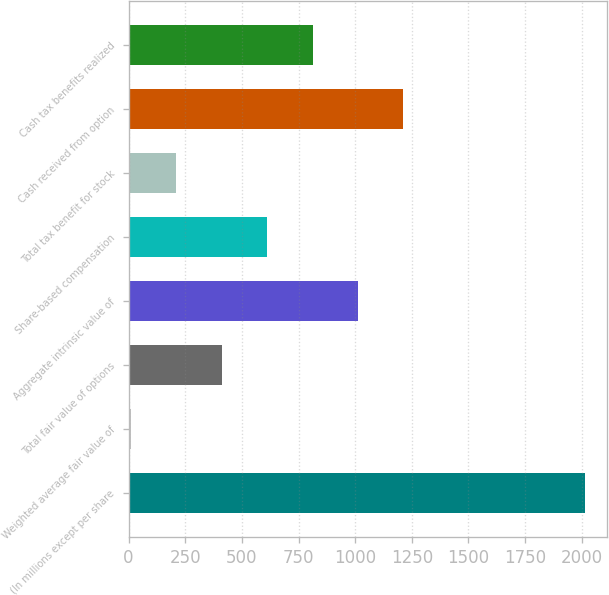Convert chart. <chart><loc_0><loc_0><loc_500><loc_500><bar_chart><fcel>(In millions except per share<fcel>Weighted average fair value of<fcel>Total fair value of options<fcel>Aggregate intrinsic value of<fcel>Share-based compensation<fcel>Total tax benefit for stock<fcel>Cash received from option<fcel>Cash tax benefits realized<nl><fcel>2013<fcel>11.24<fcel>411.6<fcel>1012.14<fcel>611.78<fcel>211.42<fcel>1212.32<fcel>811.96<nl></chart> 